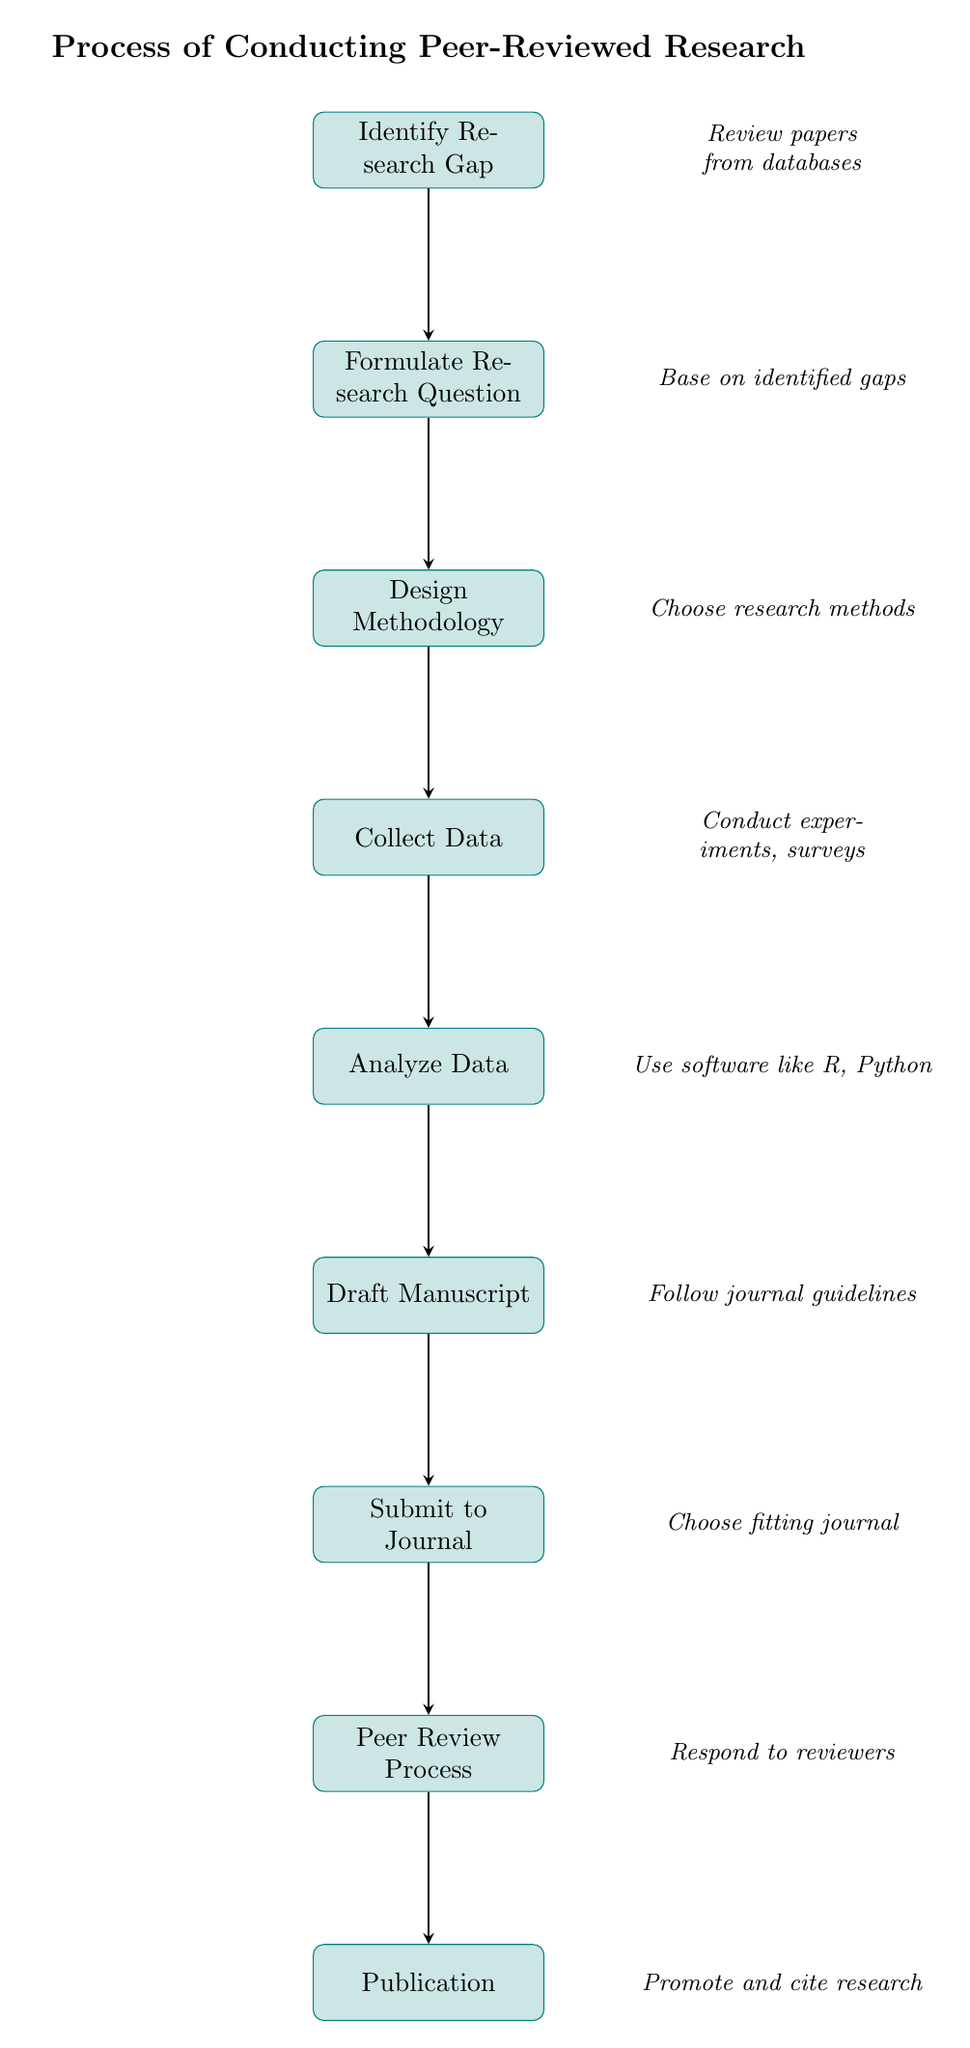What is the first step in the research process? The first step, as shown in the flow chart, is to "Identify Research Gap". This is the starting point for conducting peer-reviewed research.
Answer: Identify Research Gap How many nodes are in the diagram? The diagram consists of nine nodes, representing different steps in the research process. Counting the nodes listed in the diagram confirms this total.
Answer: Nine What action is taken after "Collect Data"? The action taken after "Collect Data" is "Analyze Data". This relationship is indicated by the arrow connecting these two nodes in the diagram.
Answer: Analyze Data Which node follows "Draft Manuscript"? The node that follows "Draft Manuscript" is "Submit to Journal". This can be determined by the direct flow from "Draft Manuscript" in the flow chart.
Answer: Submit to Journal What is the last step of the research process? The last step indicated in the flow chart is "Publication". This is where the final output of the research process is achieved.
Answer: Publication Which step involves responding to reviewers? The step that involves responding to reviewers is the "Peer Review Process". This node explicitly states that feedback is received from experts in this stage.
Answer: Peer Review Process What is the relationship between "Formulate Research Question" and "Design Methodology"? The relationship is sequential, where "Formulate Research Question" directly leads into "Design Methodology". This indicates that the formulation of a research question is necessary before designing the methodology.
Answer: Sequential In which step is data gathered? Data is gathered in the "Collect Data" step. This node clearly defines the action of gathering relevant data for the study.
Answer: Collect Data What types of methods can be chosen in the "Design Methodology" step? In the "Design Methodology" step, the methods that can be chosen include qualitative, quantitative, or mixed methods, as outlined in the diagram.
Answer: Qualitative, quantitative, mixed methods 